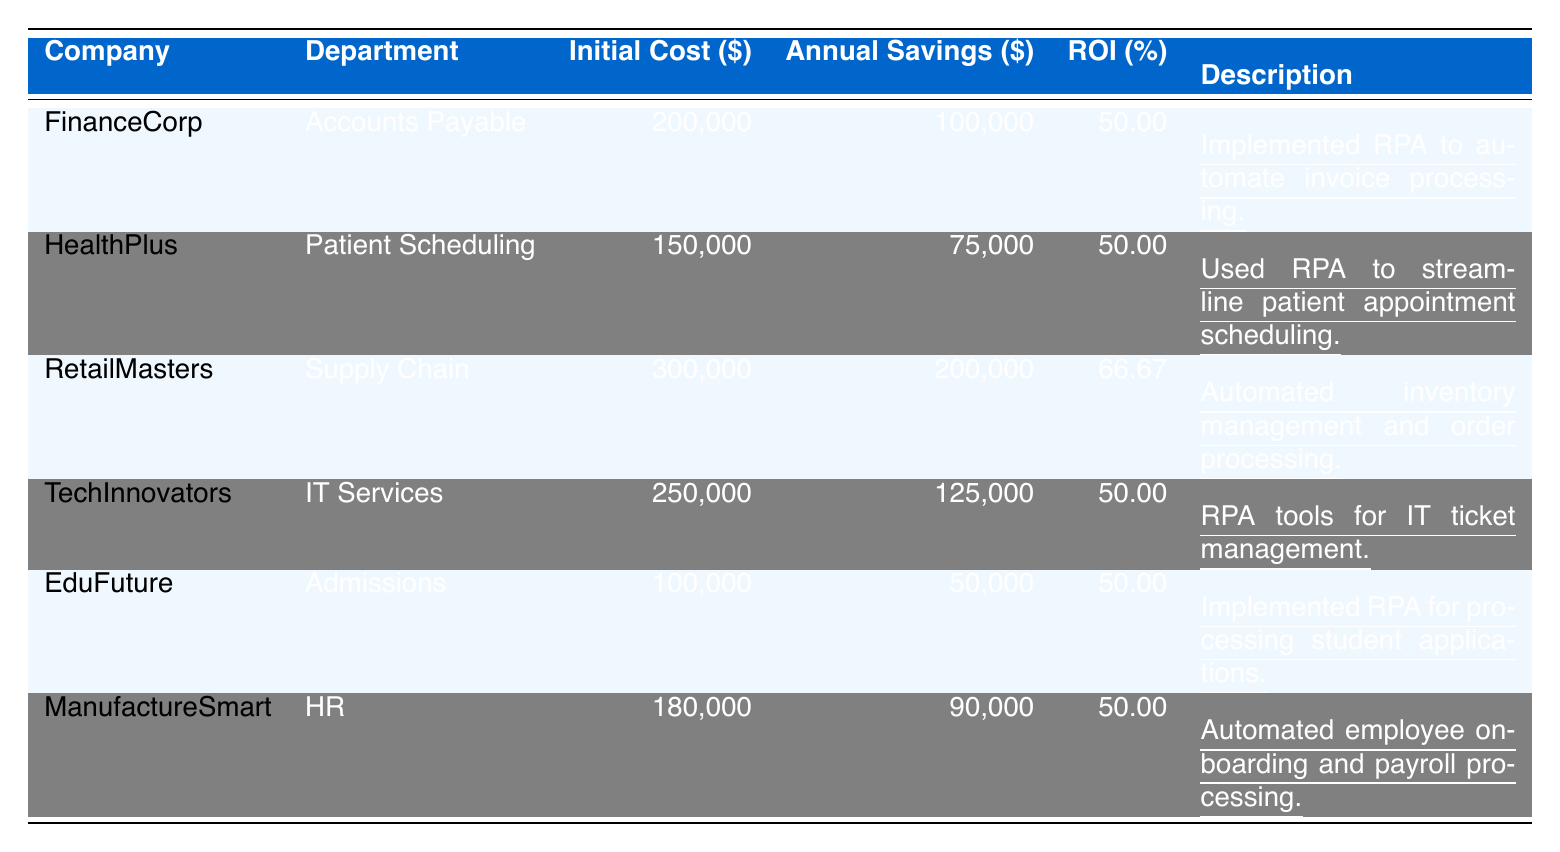What is the highest annual savings achieved among the companies listed? By scanning the "Annual Savings" column, the largest value is found under "RetailMasters" which shows $200,000 in annual savings.
Answer: 200000 Which company had the lowest initial cost for implementing RPA? Looking at the "Initial Cost" column, "EduFuture" has the lowest figure at $100,000.
Answer: 100000 What percentage ROI did "HealthPlus" achieve from its RPA initiative? The table shows that "HealthPlus" has an ROI of 50%, directly stated in the corresponding column.
Answer: 50 Which department saved a total of $90,000 annually from its RPA initiative? The "ManufactureSmart" entry under the "Annual Savings" column indicates an annual savings of $90,000.
Answer: HR What is the average ROI for all companies listed in the table? The ROI values are 50, 50, 66.67, 50, 50, and 50. Calculating the average: (50 + 50 + 66.67 + 50 + 50 + 50) / 6 = 52.78.
Answer: 52.78 Is the initial cost for "FinanceCorp" greater than the initial cost for "EduFuture"? "FinanceCorp" shows an initial cost of $200,000 while "EduFuture" shows $100,000, confirming that $200,000 is greater than $100,000.
Answer: Yes How much total initial cost was incurred by all companies? Adding up all the initial costs: 200000 + 150000 + 300000 + 250000 + 100000 + 180000 = 1180000.
Answer: 1180000 Which two companies achieved the same ROI percentage? Comparing the ROI values, both "FinanceCorp" and "HealthPlus" have 50% ROI.
Answer: FinanceCorp and HealthPlus What would be the total annual savings if "TechInnovators" and "EduFuture" combined their savings? Adding their annual savings together: 125000 (TechInnovators) + 50000 (EduFuture) = 175000.
Answer: 175000 Is it true that all departments that implemented RPA achieved a ROI of at least 50%? Reviewing the ROI column reveals that every company listed has a ROI of either 50 or greater, confirming this statement as true.
Answer: True 